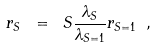Convert formula to latex. <formula><loc_0><loc_0><loc_500><loc_500>r _ { S } \ = \ S \frac { \lambda _ { S } } { \lambda _ { S = 1 } } r _ { S = 1 } \ ,</formula> 